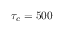<formula> <loc_0><loc_0><loc_500><loc_500>\tau _ { c } = 5 0 0</formula> 